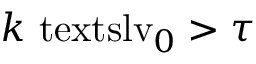Convert formula to latex. <formula><loc_0><loc_0><loc_500><loc_500>k { \ t e x t s l { v } _ { 0 } } > \tau</formula> 